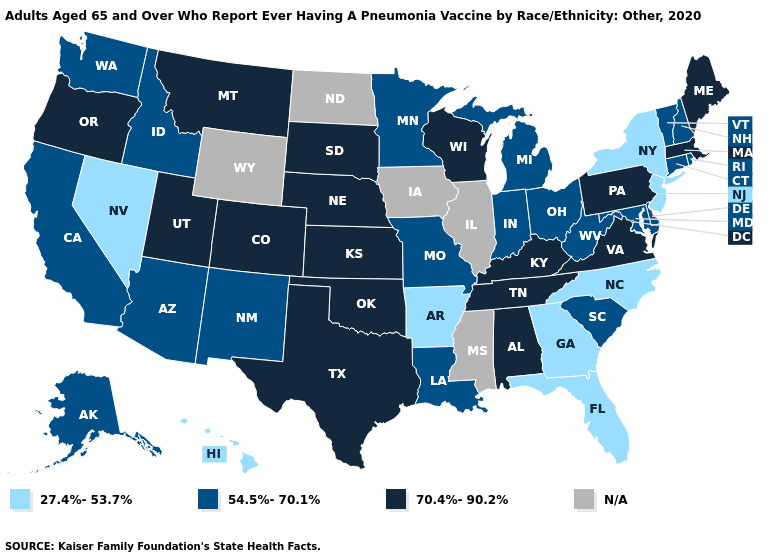Which states have the lowest value in the Northeast?
Be succinct. New Jersey, New York. What is the highest value in the MidWest ?
Give a very brief answer. 70.4%-90.2%. What is the lowest value in the West?
Write a very short answer. 27.4%-53.7%. Name the states that have a value in the range N/A?
Be succinct. Illinois, Iowa, Mississippi, North Dakota, Wyoming. Name the states that have a value in the range 27.4%-53.7%?
Give a very brief answer. Arkansas, Florida, Georgia, Hawaii, Nevada, New Jersey, New York, North Carolina. Among the states that border Rhode Island , does Connecticut have the highest value?
Write a very short answer. No. Name the states that have a value in the range 54.5%-70.1%?
Concise answer only. Alaska, Arizona, California, Connecticut, Delaware, Idaho, Indiana, Louisiana, Maryland, Michigan, Minnesota, Missouri, New Hampshire, New Mexico, Ohio, Rhode Island, South Carolina, Vermont, Washington, West Virginia. What is the value of Nevada?
Concise answer only. 27.4%-53.7%. Among the states that border Florida , which have the lowest value?
Quick response, please. Georgia. Name the states that have a value in the range 27.4%-53.7%?
Keep it brief. Arkansas, Florida, Georgia, Hawaii, Nevada, New Jersey, New York, North Carolina. Name the states that have a value in the range N/A?
Short answer required. Illinois, Iowa, Mississippi, North Dakota, Wyoming. What is the value of Massachusetts?
Keep it brief. 70.4%-90.2%. Among the states that border Arkansas , does Texas have the highest value?
Short answer required. Yes. What is the value of Michigan?
Quick response, please. 54.5%-70.1%. 